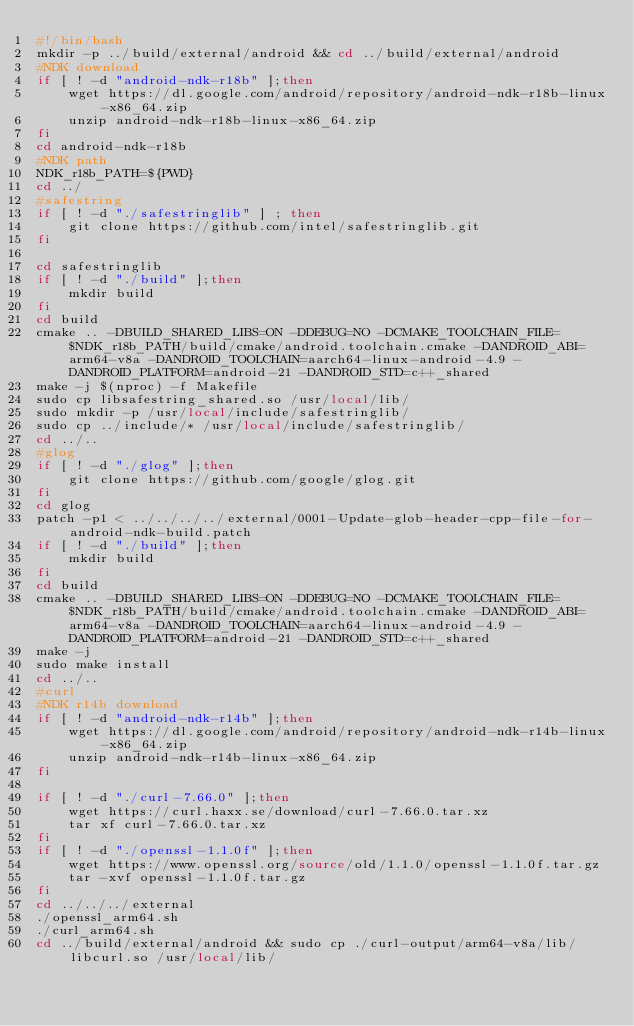<code> <loc_0><loc_0><loc_500><loc_500><_Bash_>#!/bin/bash
mkdir -p ../build/external/android && cd ../build/external/android
#NDK download
if [ ! -d "android-ndk-r18b" ];then
    wget https://dl.google.com/android/repository/android-ndk-r18b-linux-x86_64.zip
    unzip android-ndk-r18b-linux-x86_64.zip
fi
cd android-ndk-r18b
#NDK path
NDK_r18b_PATH=${PWD}
cd ../
#safestring
if [ ! -d "./safestringlib" ] ; then
    git clone https://github.com/intel/safestringlib.git
fi

cd safestringlib
if [ ! -d "./build" ];then
    mkdir build
fi
cd build
cmake .. -DBUILD_SHARED_LIBS=ON -DDEBUG=NO -DCMAKE_TOOLCHAIN_FILE=$NDK_r18b_PATH/build/cmake/android.toolchain.cmake -DANDROID_ABI=arm64-v8a -DANDROID_TOOLCHAIN=aarch64-linux-android-4.9 -DANDROID_PLATFORM=android-21 -DANDROID_STD=c++_shared
make -j $(nproc) -f Makefile
sudo cp libsafestring_shared.so /usr/local/lib/
sudo mkdir -p /usr/local/include/safestringlib/
sudo cp ../include/* /usr/local/include/safestringlib/
cd ../..
#glog
if [ ! -d "./glog" ];then
    git clone https://github.com/google/glog.git
fi
cd glog
patch -p1 < ../../../../external/0001-Update-glob-header-cpp-file-for-android-ndk-build.patch
if [ ! -d "./build" ];then
    mkdir build
fi
cd build
cmake .. -DBUILD_SHARED_LIBS=ON -DDEBUG=NO -DCMAKE_TOOLCHAIN_FILE=$NDK_r18b_PATH/build/cmake/android.toolchain.cmake -DANDROID_ABI=arm64-v8a -DANDROID_TOOLCHAIN=aarch64-linux-android-4.9 -DANDROID_PLATFORM=android-21 -DANDROID_STD=c++_shared
make -j
sudo make install
cd ../..
#curl
#NDK r14b download
if [ ! -d "android-ndk-r14b" ];then
    wget https://dl.google.com/android/repository/android-ndk-r14b-linux-x86_64.zip
    unzip android-ndk-r14b-linux-x86_64.zip
fi

if [ ! -d "./curl-7.66.0" ];then
    wget https://curl.haxx.se/download/curl-7.66.0.tar.xz
    tar xf curl-7.66.0.tar.xz
fi
if [ ! -d "./openssl-1.1.0f" ];then
    wget https://www.openssl.org/source/old/1.1.0/openssl-1.1.0f.tar.gz
    tar -xvf openssl-1.1.0f.tar.gz
fi
cd ../../../external
./openssl_arm64.sh
./curl_arm64.sh
cd ../build/external/android && sudo cp ./curl-output/arm64-v8a/lib/libcurl.so /usr/local/lib/
</code> 